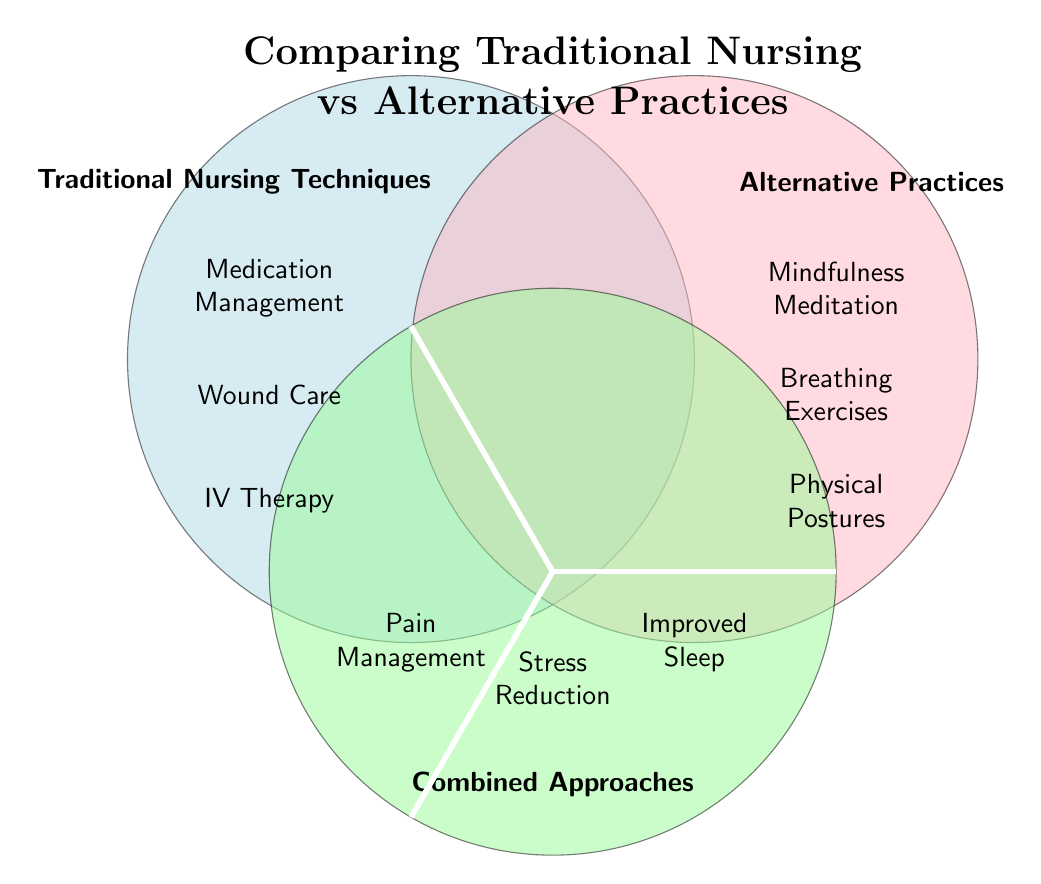What are three traditional nursing techniques listed in the diagram? The diagram shows traditional nursing techniques in the left circle. They are Medication Management, Wound Care, and IV Therapy, which can be found in the respective labeled areas.
Answer: Medication Management, Wound Care, IV Therapy What are three alternative practices listed in the diagram? The diagram shows alternative practices in the right circle. They include Mindfulness Meditation, Breathing Exercises, and Physical Postures, which are noted in the respective areas of the labeled circle.
Answer: Mindfulness Meditation, Breathing Exercises, Physical Postures How many combined approaches are listed in the diagram? The bottom circle labeled Combined Approaches contains three distinct items: Pain Management, Stress Reduction, and Improved Sleep, which counts as three unique items in that area.
Answer: 3 What is a combined approach related to stress in the diagram? The diagram shows Stress Reduction in the combined approaches area, indicating it is a theme that blends both traditional and alternative practices for patient care outcomes.
Answer: Stress Reduction Which traditional nursing technique is closest to alternative practices in the diagram? Upon examining the overlap in the Venn diagram, one can see that there is no direct overlap; however, both sides may share themes in items related to patient care. In this case, the traditional nursing technique does not list a specific name in that area.
Answer: None 